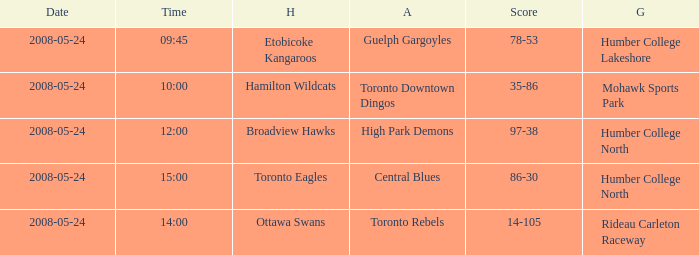Who was the away team of the game at the time 15:00? Central Blues. 